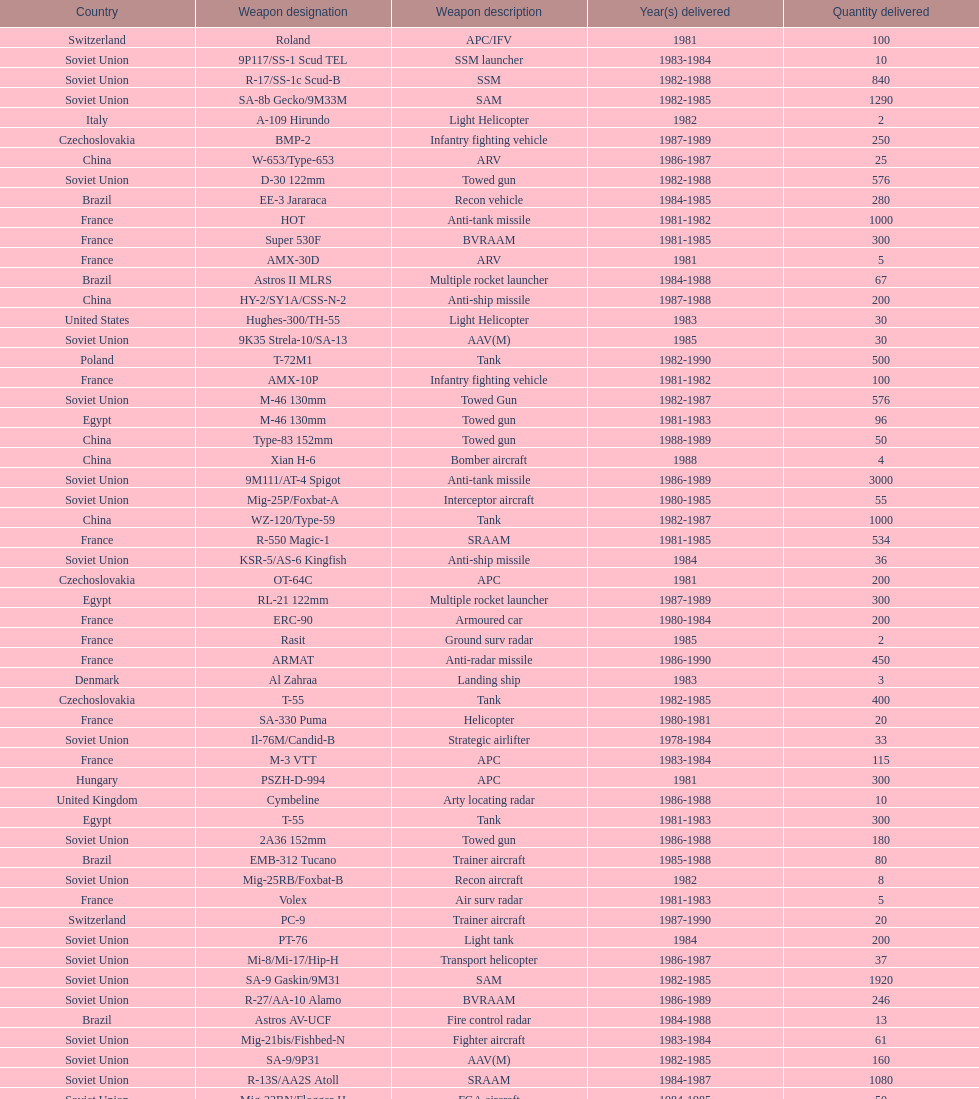Which was the first country to sell weapons to iraq? Czechoslovakia. 